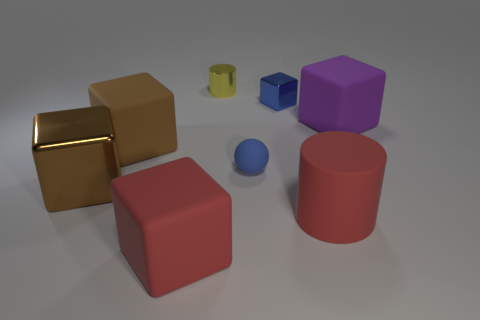Subtract 2 blocks. How many blocks are left? 3 Subtract all large red matte cubes. How many cubes are left? 4 Subtract all purple blocks. How many blocks are left? 4 Subtract all green cubes. Subtract all blue cylinders. How many cubes are left? 5 Add 2 metallic balls. How many objects exist? 10 Subtract all cylinders. How many objects are left? 6 Subtract 0 brown spheres. How many objects are left? 8 Subtract all brown things. Subtract all big red rubber cylinders. How many objects are left? 5 Add 5 small blue objects. How many small blue objects are left? 7 Add 2 large brown cubes. How many large brown cubes exist? 4 